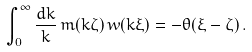Convert formula to latex. <formula><loc_0><loc_0><loc_500><loc_500>\int _ { 0 } ^ { \infty } \frac { d k } { k } \, m ( k \zeta ) \, w ( k \xi ) = - \theta ( \xi - \zeta ) \, .</formula> 